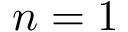<formula> <loc_0><loc_0><loc_500><loc_500>n = 1</formula> 